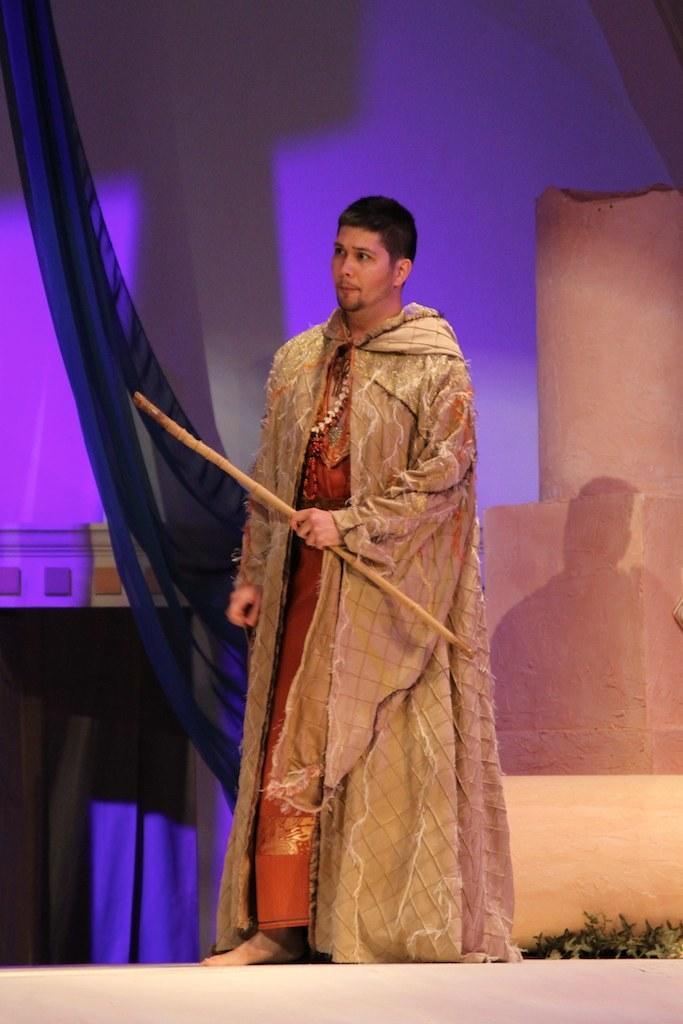Can you describe this image briefly? In this image, we can see a person is holding some stick. At the bottom, we can see few plants. Background there is a wall, few clothes. 